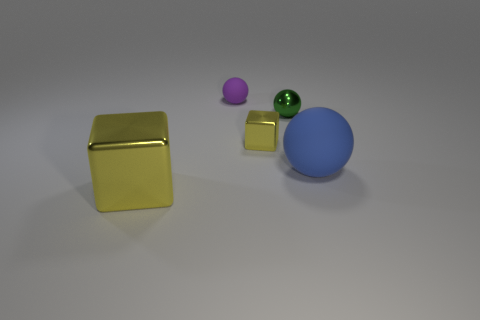How many shiny things are either tiny brown cylinders or small blocks?
Ensure brevity in your answer.  1. Are there any other things that are the same material as the purple thing?
Provide a succinct answer. Yes. How big is the block in front of the large object on the right side of the yellow metallic block that is right of the purple rubber thing?
Keep it short and to the point. Large. How big is the object that is both in front of the tiny yellow metallic cube and behind the large yellow metallic block?
Keep it short and to the point. Large. Is the color of the metallic cube that is on the right side of the purple ball the same as the rubber object behind the large blue matte sphere?
Give a very brief answer. No. There is a green metallic ball; how many large blue balls are behind it?
Your answer should be very brief. 0. Is there a yellow metallic cube behind the matte sphere that is right of the metallic block behind the large cube?
Offer a terse response. Yes. What number of green balls are the same size as the blue thing?
Offer a terse response. 0. The yellow thing in front of the yellow object that is behind the big blue rubber object is made of what material?
Provide a short and direct response. Metal. There is a big thing behind the yellow metallic thing on the left side of the tiny thing that is in front of the green metal ball; what shape is it?
Your response must be concise. Sphere. 